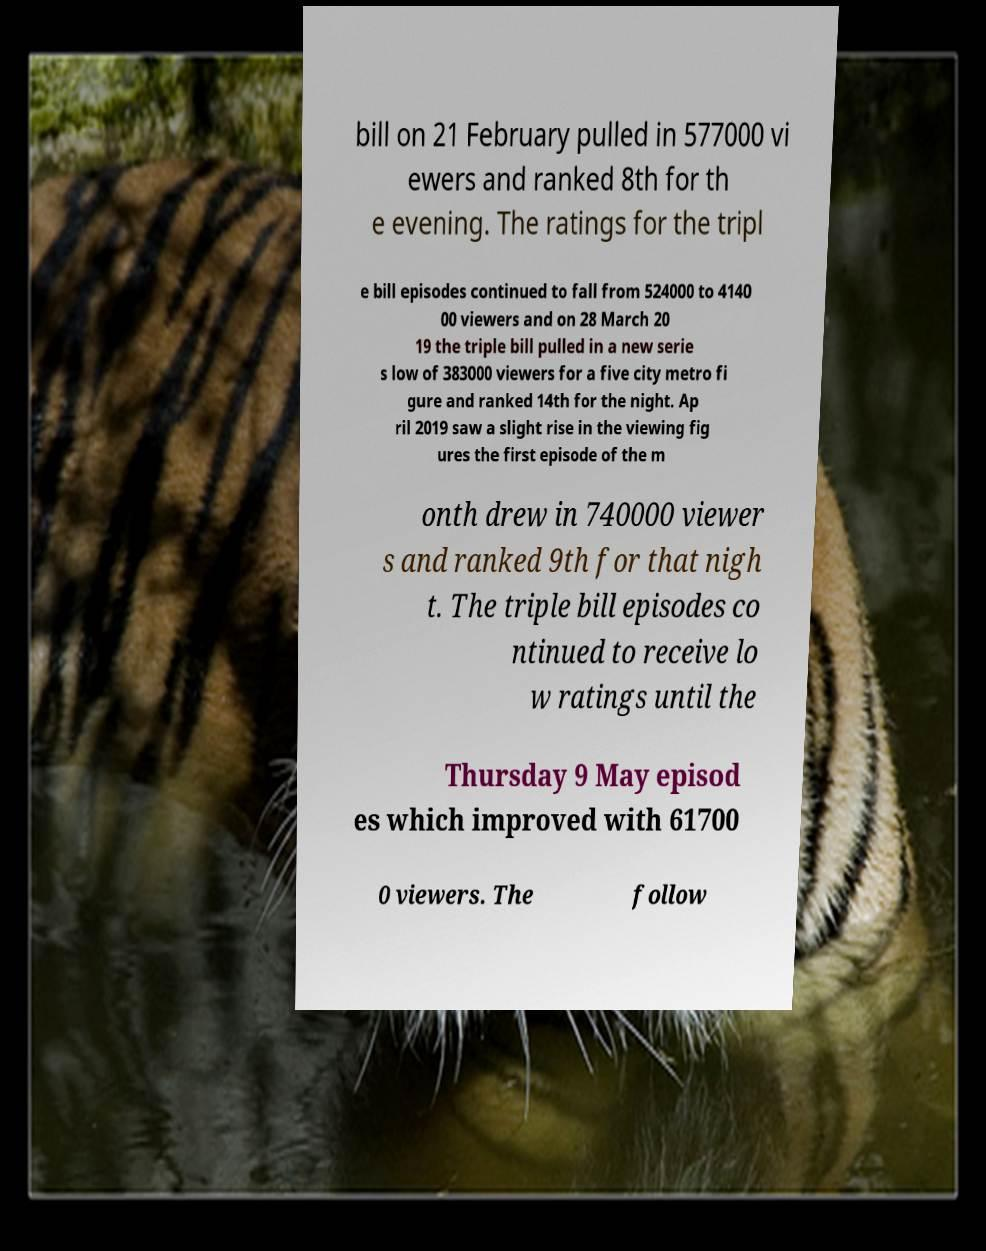I need the written content from this picture converted into text. Can you do that? bill on 21 February pulled in 577000 vi ewers and ranked 8th for th e evening. The ratings for the tripl e bill episodes continued to fall from 524000 to 4140 00 viewers and on 28 March 20 19 the triple bill pulled in a new serie s low of 383000 viewers for a five city metro fi gure and ranked 14th for the night. Ap ril 2019 saw a slight rise in the viewing fig ures the first episode of the m onth drew in 740000 viewer s and ranked 9th for that nigh t. The triple bill episodes co ntinued to receive lo w ratings until the Thursday 9 May episod es which improved with 61700 0 viewers. The follow 